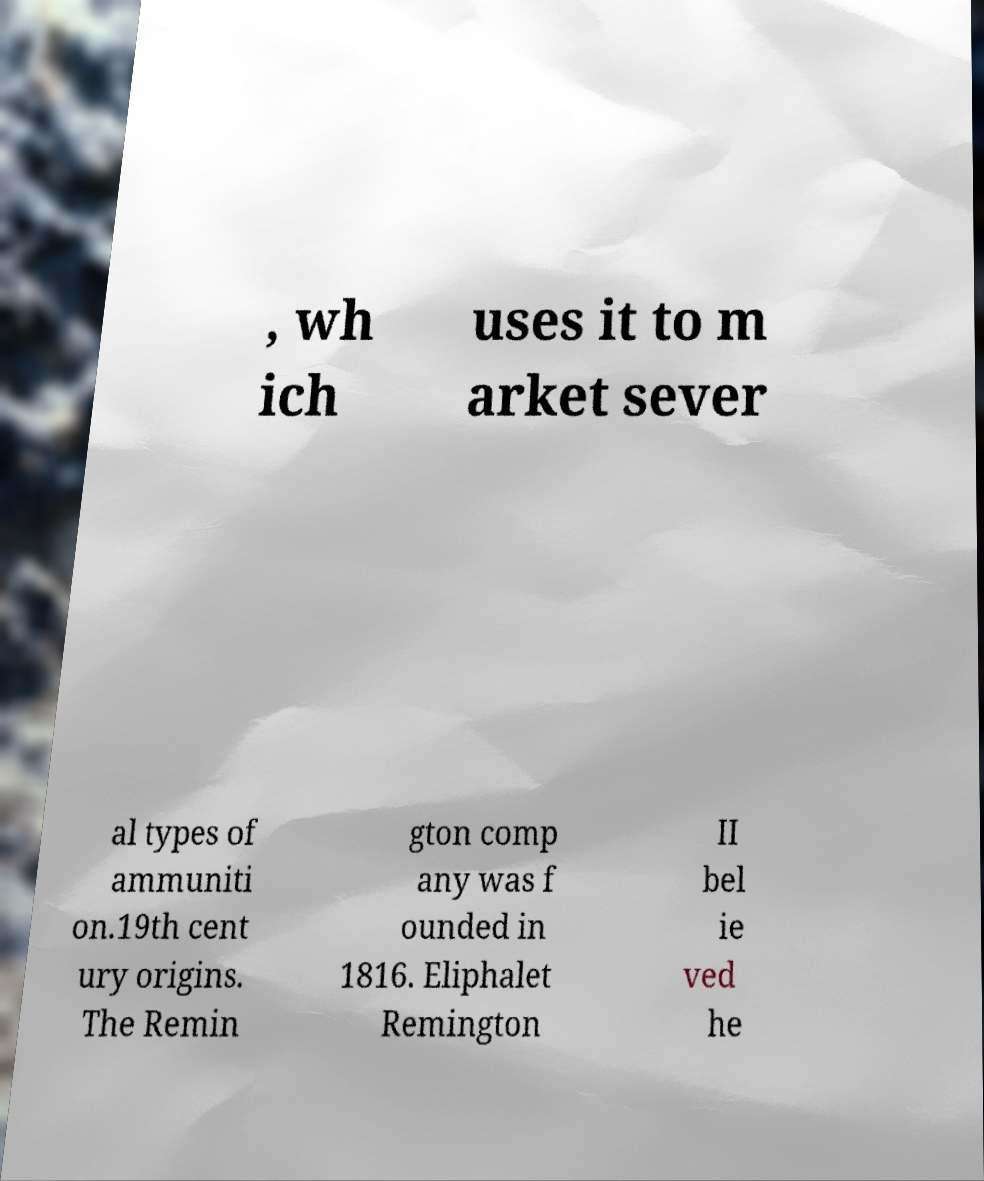Please read and relay the text visible in this image. What does it say? , wh ich uses it to m arket sever al types of ammuniti on.19th cent ury origins. The Remin gton comp any was f ounded in 1816. Eliphalet Remington II bel ie ved he 